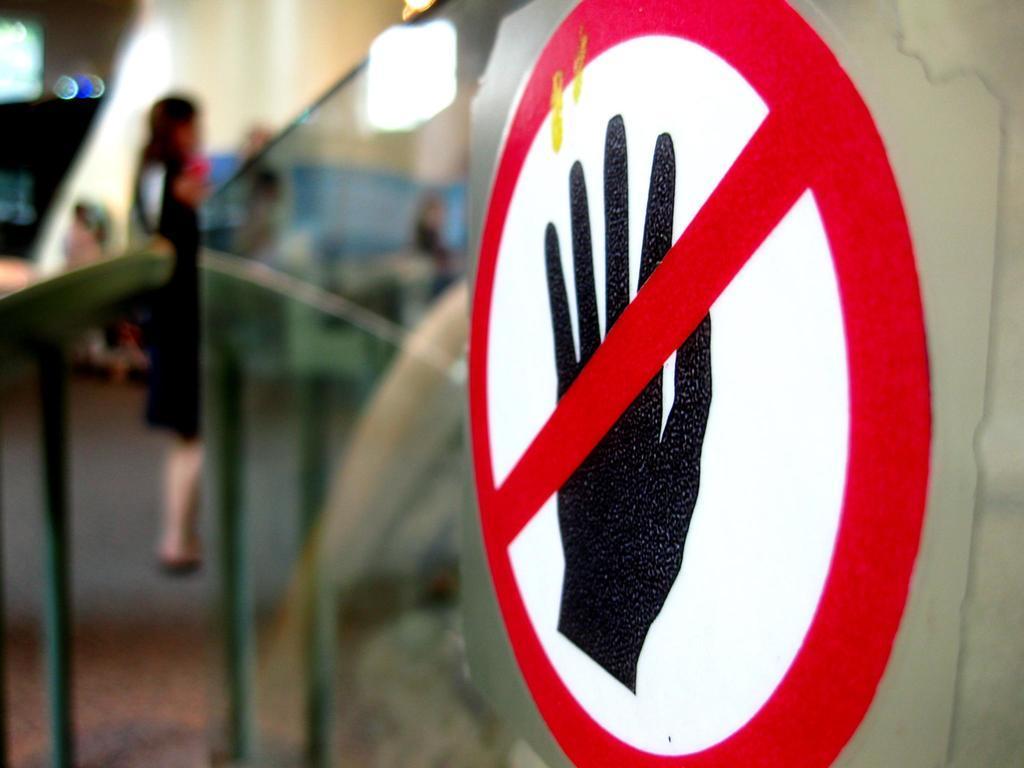Describe this image in one or two sentences. In this image in the center there is a sign board. In the background there is a woman standing and there is a glass in the center. 